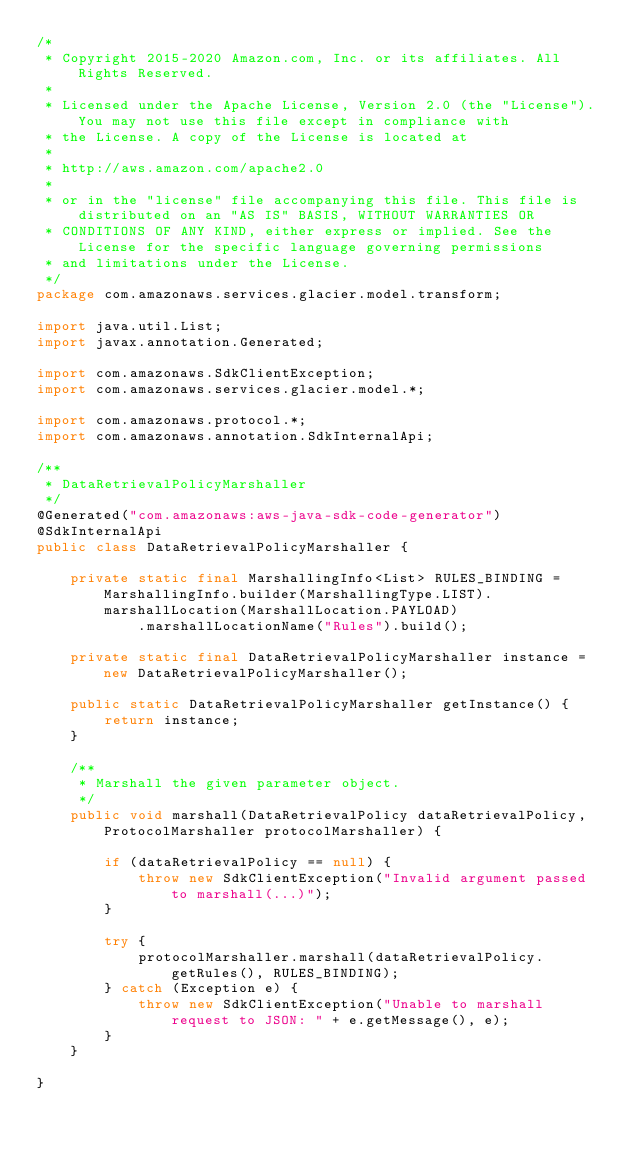<code> <loc_0><loc_0><loc_500><loc_500><_Java_>/*
 * Copyright 2015-2020 Amazon.com, Inc. or its affiliates. All Rights Reserved.
 * 
 * Licensed under the Apache License, Version 2.0 (the "License"). You may not use this file except in compliance with
 * the License. A copy of the License is located at
 * 
 * http://aws.amazon.com/apache2.0
 * 
 * or in the "license" file accompanying this file. This file is distributed on an "AS IS" BASIS, WITHOUT WARRANTIES OR
 * CONDITIONS OF ANY KIND, either express or implied. See the License for the specific language governing permissions
 * and limitations under the License.
 */
package com.amazonaws.services.glacier.model.transform;

import java.util.List;
import javax.annotation.Generated;

import com.amazonaws.SdkClientException;
import com.amazonaws.services.glacier.model.*;

import com.amazonaws.protocol.*;
import com.amazonaws.annotation.SdkInternalApi;

/**
 * DataRetrievalPolicyMarshaller
 */
@Generated("com.amazonaws:aws-java-sdk-code-generator")
@SdkInternalApi
public class DataRetrievalPolicyMarshaller {

    private static final MarshallingInfo<List> RULES_BINDING = MarshallingInfo.builder(MarshallingType.LIST).marshallLocation(MarshallLocation.PAYLOAD)
            .marshallLocationName("Rules").build();

    private static final DataRetrievalPolicyMarshaller instance = new DataRetrievalPolicyMarshaller();

    public static DataRetrievalPolicyMarshaller getInstance() {
        return instance;
    }

    /**
     * Marshall the given parameter object.
     */
    public void marshall(DataRetrievalPolicy dataRetrievalPolicy, ProtocolMarshaller protocolMarshaller) {

        if (dataRetrievalPolicy == null) {
            throw new SdkClientException("Invalid argument passed to marshall(...)");
        }

        try {
            protocolMarshaller.marshall(dataRetrievalPolicy.getRules(), RULES_BINDING);
        } catch (Exception e) {
            throw new SdkClientException("Unable to marshall request to JSON: " + e.getMessage(), e);
        }
    }

}
</code> 